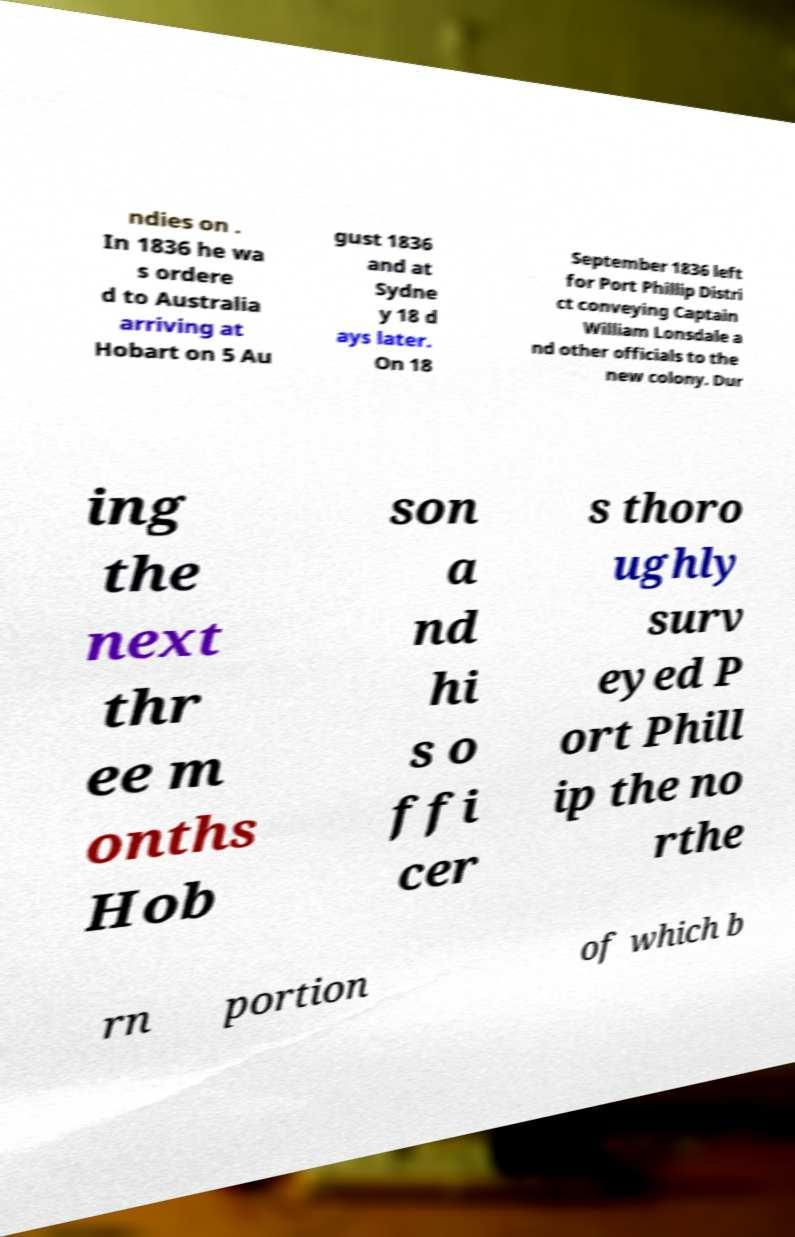I need the written content from this picture converted into text. Can you do that? ndies on . In 1836 he wa s ordere d to Australia arriving at Hobart on 5 Au gust 1836 and at Sydne y 18 d ays later. On 18 September 1836 left for Port Phillip Distri ct conveying Captain William Lonsdale a nd other officials to the new colony. Dur ing the next thr ee m onths Hob son a nd hi s o ffi cer s thoro ughly surv eyed P ort Phill ip the no rthe rn portion of which b 